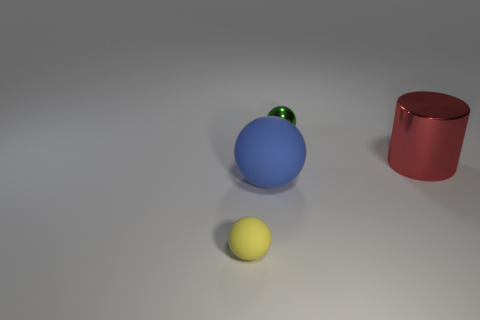What can you infer about the lighting in this scene? The lighting within the scene comes from above as indicated by the shadows cast by the spheres and the cylinder on the ground. The softness of the shadows suggests the source may be diffused, providing gentle, ambient illumination. 